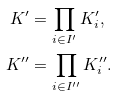<formula> <loc_0><loc_0><loc_500><loc_500>K ^ { \prime } & = \prod _ { i \in I ^ { \prime } } K ^ { \prime } _ { i } , \\ K ^ { \prime \prime } & = \prod _ { i \in I ^ { \prime \prime } } K ^ { \prime \prime } _ { i } .</formula> 